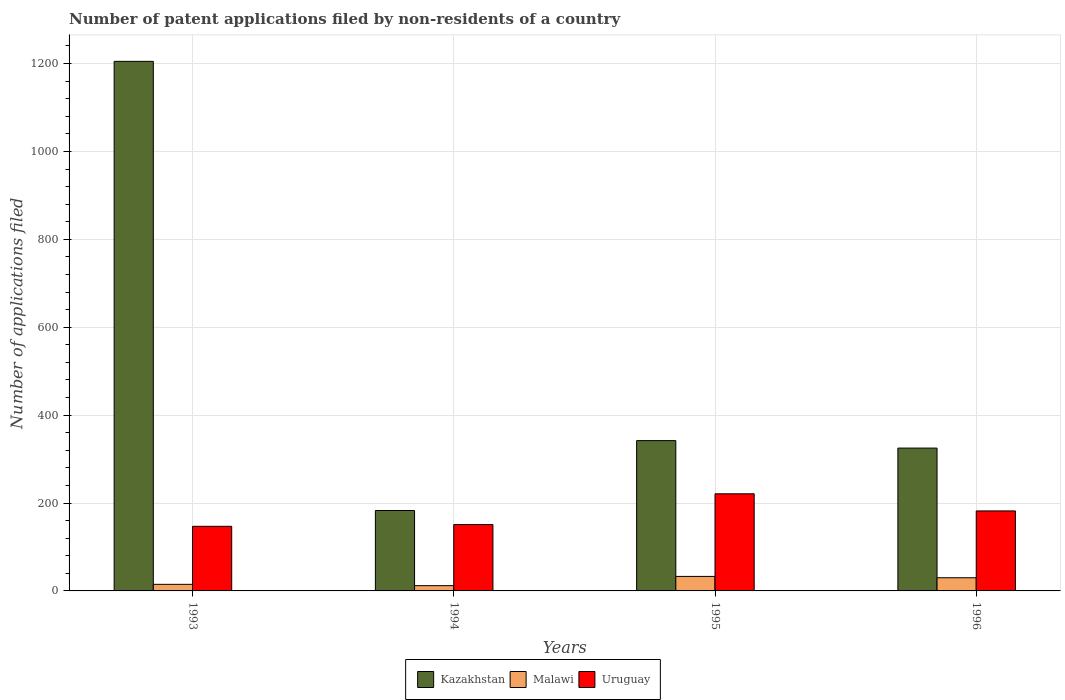How many groups of bars are there?
Offer a very short reply. 4. Are the number of bars per tick equal to the number of legend labels?
Make the answer very short. Yes. Are the number of bars on each tick of the X-axis equal?
Offer a terse response. Yes. How many bars are there on the 4th tick from the left?
Ensure brevity in your answer.  3. What is the label of the 1st group of bars from the left?
Your answer should be compact. 1993. What is the number of applications filed in Malawi in 1995?
Keep it short and to the point. 33. Across all years, what is the maximum number of applications filed in Kazakhstan?
Provide a short and direct response. 1205. In which year was the number of applications filed in Malawi maximum?
Ensure brevity in your answer.  1995. In which year was the number of applications filed in Uruguay minimum?
Ensure brevity in your answer.  1993. What is the total number of applications filed in Kazakhstan in the graph?
Offer a terse response. 2055. What is the difference between the number of applications filed in Kazakhstan in 1993 and that in 1995?
Make the answer very short. 863. What is the difference between the number of applications filed in Malawi in 1993 and the number of applications filed in Kazakhstan in 1995?
Offer a terse response. -327. What is the average number of applications filed in Uruguay per year?
Your answer should be very brief. 175.25. In the year 1995, what is the difference between the number of applications filed in Malawi and number of applications filed in Kazakhstan?
Provide a succinct answer. -309. What is the ratio of the number of applications filed in Uruguay in 1994 to that in 1996?
Offer a very short reply. 0.83. Is the difference between the number of applications filed in Malawi in 1994 and 1996 greater than the difference between the number of applications filed in Kazakhstan in 1994 and 1996?
Ensure brevity in your answer.  Yes. What is the difference between the highest and the second highest number of applications filed in Uruguay?
Provide a succinct answer. 39. In how many years, is the number of applications filed in Kazakhstan greater than the average number of applications filed in Kazakhstan taken over all years?
Provide a short and direct response. 1. What does the 2nd bar from the left in 1994 represents?
Provide a short and direct response. Malawi. What does the 2nd bar from the right in 1994 represents?
Offer a terse response. Malawi. Is it the case that in every year, the sum of the number of applications filed in Uruguay and number of applications filed in Malawi is greater than the number of applications filed in Kazakhstan?
Give a very brief answer. No. How many bars are there?
Your answer should be compact. 12. How many years are there in the graph?
Give a very brief answer. 4. Does the graph contain grids?
Ensure brevity in your answer.  Yes. How many legend labels are there?
Give a very brief answer. 3. How are the legend labels stacked?
Provide a short and direct response. Horizontal. What is the title of the graph?
Your answer should be very brief. Number of patent applications filed by non-residents of a country. Does "Angola" appear as one of the legend labels in the graph?
Make the answer very short. No. What is the label or title of the X-axis?
Keep it short and to the point. Years. What is the label or title of the Y-axis?
Ensure brevity in your answer.  Number of applications filed. What is the Number of applications filed of Kazakhstan in 1993?
Provide a succinct answer. 1205. What is the Number of applications filed of Uruguay in 1993?
Provide a short and direct response. 147. What is the Number of applications filed in Kazakhstan in 1994?
Offer a very short reply. 183. What is the Number of applications filed of Malawi in 1994?
Provide a short and direct response. 12. What is the Number of applications filed of Uruguay in 1994?
Ensure brevity in your answer.  151. What is the Number of applications filed of Kazakhstan in 1995?
Keep it short and to the point. 342. What is the Number of applications filed of Malawi in 1995?
Your response must be concise. 33. What is the Number of applications filed in Uruguay in 1995?
Ensure brevity in your answer.  221. What is the Number of applications filed of Kazakhstan in 1996?
Offer a very short reply. 325. What is the Number of applications filed in Malawi in 1996?
Offer a terse response. 30. What is the Number of applications filed of Uruguay in 1996?
Your response must be concise. 182. Across all years, what is the maximum Number of applications filed in Kazakhstan?
Offer a terse response. 1205. Across all years, what is the maximum Number of applications filed in Uruguay?
Make the answer very short. 221. Across all years, what is the minimum Number of applications filed in Kazakhstan?
Offer a very short reply. 183. Across all years, what is the minimum Number of applications filed in Uruguay?
Your answer should be very brief. 147. What is the total Number of applications filed of Kazakhstan in the graph?
Give a very brief answer. 2055. What is the total Number of applications filed in Uruguay in the graph?
Your response must be concise. 701. What is the difference between the Number of applications filed of Kazakhstan in 1993 and that in 1994?
Your answer should be very brief. 1022. What is the difference between the Number of applications filed of Malawi in 1993 and that in 1994?
Ensure brevity in your answer.  3. What is the difference between the Number of applications filed of Kazakhstan in 1993 and that in 1995?
Make the answer very short. 863. What is the difference between the Number of applications filed of Uruguay in 1993 and that in 1995?
Your answer should be compact. -74. What is the difference between the Number of applications filed in Kazakhstan in 1993 and that in 1996?
Offer a terse response. 880. What is the difference between the Number of applications filed of Malawi in 1993 and that in 1996?
Provide a succinct answer. -15. What is the difference between the Number of applications filed in Uruguay in 1993 and that in 1996?
Make the answer very short. -35. What is the difference between the Number of applications filed in Kazakhstan in 1994 and that in 1995?
Provide a short and direct response. -159. What is the difference between the Number of applications filed in Uruguay in 1994 and that in 1995?
Ensure brevity in your answer.  -70. What is the difference between the Number of applications filed in Kazakhstan in 1994 and that in 1996?
Ensure brevity in your answer.  -142. What is the difference between the Number of applications filed in Malawi in 1994 and that in 1996?
Offer a terse response. -18. What is the difference between the Number of applications filed in Uruguay in 1994 and that in 1996?
Provide a short and direct response. -31. What is the difference between the Number of applications filed of Malawi in 1995 and that in 1996?
Provide a succinct answer. 3. What is the difference between the Number of applications filed in Uruguay in 1995 and that in 1996?
Provide a succinct answer. 39. What is the difference between the Number of applications filed in Kazakhstan in 1993 and the Number of applications filed in Malawi in 1994?
Your answer should be compact. 1193. What is the difference between the Number of applications filed in Kazakhstan in 1993 and the Number of applications filed in Uruguay in 1994?
Your answer should be compact. 1054. What is the difference between the Number of applications filed of Malawi in 1993 and the Number of applications filed of Uruguay in 1994?
Your answer should be compact. -136. What is the difference between the Number of applications filed of Kazakhstan in 1993 and the Number of applications filed of Malawi in 1995?
Offer a very short reply. 1172. What is the difference between the Number of applications filed of Kazakhstan in 1993 and the Number of applications filed of Uruguay in 1995?
Ensure brevity in your answer.  984. What is the difference between the Number of applications filed of Malawi in 1993 and the Number of applications filed of Uruguay in 1995?
Make the answer very short. -206. What is the difference between the Number of applications filed of Kazakhstan in 1993 and the Number of applications filed of Malawi in 1996?
Your answer should be compact. 1175. What is the difference between the Number of applications filed in Kazakhstan in 1993 and the Number of applications filed in Uruguay in 1996?
Your answer should be very brief. 1023. What is the difference between the Number of applications filed in Malawi in 1993 and the Number of applications filed in Uruguay in 1996?
Offer a terse response. -167. What is the difference between the Number of applications filed of Kazakhstan in 1994 and the Number of applications filed of Malawi in 1995?
Offer a very short reply. 150. What is the difference between the Number of applications filed of Kazakhstan in 1994 and the Number of applications filed of Uruguay in 1995?
Your answer should be very brief. -38. What is the difference between the Number of applications filed in Malawi in 1994 and the Number of applications filed in Uruguay in 1995?
Offer a terse response. -209. What is the difference between the Number of applications filed in Kazakhstan in 1994 and the Number of applications filed in Malawi in 1996?
Give a very brief answer. 153. What is the difference between the Number of applications filed in Malawi in 1994 and the Number of applications filed in Uruguay in 1996?
Your response must be concise. -170. What is the difference between the Number of applications filed of Kazakhstan in 1995 and the Number of applications filed of Malawi in 1996?
Give a very brief answer. 312. What is the difference between the Number of applications filed of Kazakhstan in 1995 and the Number of applications filed of Uruguay in 1996?
Offer a very short reply. 160. What is the difference between the Number of applications filed of Malawi in 1995 and the Number of applications filed of Uruguay in 1996?
Your response must be concise. -149. What is the average Number of applications filed of Kazakhstan per year?
Make the answer very short. 513.75. What is the average Number of applications filed of Uruguay per year?
Make the answer very short. 175.25. In the year 1993, what is the difference between the Number of applications filed in Kazakhstan and Number of applications filed in Malawi?
Provide a short and direct response. 1190. In the year 1993, what is the difference between the Number of applications filed of Kazakhstan and Number of applications filed of Uruguay?
Keep it short and to the point. 1058. In the year 1993, what is the difference between the Number of applications filed in Malawi and Number of applications filed in Uruguay?
Make the answer very short. -132. In the year 1994, what is the difference between the Number of applications filed in Kazakhstan and Number of applications filed in Malawi?
Provide a short and direct response. 171. In the year 1994, what is the difference between the Number of applications filed in Kazakhstan and Number of applications filed in Uruguay?
Provide a succinct answer. 32. In the year 1994, what is the difference between the Number of applications filed in Malawi and Number of applications filed in Uruguay?
Your answer should be very brief. -139. In the year 1995, what is the difference between the Number of applications filed in Kazakhstan and Number of applications filed in Malawi?
Ensure brevity in your answer.  309. In the year 1995, what is the difference between the Number of applications filed in Kazakhstan and Number of applications filed in Uruguay?
Make the answer very short. 121. In the year 1995, what is the difference between the Number of applications filed in Malawi and Number of applications filed in Uruguay?
Offer a very short reply. -188. In the year 1996, what is the difference between the Number of applications filed in Kazakhstan and Number of applications filed in Malawi?
Your response must be concise. 295. In the year 1996, what is the difference between the Number of applications filed in Kazakhstan and Number of applications filed in Uruguay?
Keep it short and to the point. 143. In the year 1996, what is the difference between the Number of applications filed of Malawi and Number of applications filed of Uruguay?
Provide a succinct answer. -152. What is the ratio of the Number of applications filed in Kazakhstan in 1993 to that in 1994?
Ensure brevity in your answer.  6.58. What is the ratio of the Number of applications filed in Uruguay in 1993 to that in 1994?
Provide a short and direct response. 0.97. What is the ratio of the Number of applications filed of Kazakhstan in 1993 to that in 1995?
Your response must be concise. 3.52. What is the ratio of the Number of applications filed of Malawi in 1993 to that in 1995?
Your answer should be compact. 0.45. What is the ratio of the Number of applications filed of Uruguay in 1993 to that in 1995?
Offer a very short reply. 0.67. What is the ratio of the Number of applications filed of Kazakhstan in 1993 to that in 1996?
Keep it short and to the point. 3.71. What is the ratio of the Number of applications filed in Uruguay in 1993 to that in 1996?
Make the answer very short. 0.81. What is the ratio of the Number of applications filed of Kazakhstan in 1994 to that in 1995?
Give a very brief answer. 0.54. What is the ratio of the Number of applications filed in Malawi in 1994 to that in 1995?
Your response must be concise. 0.36. What is the ratio of the Number of applications filed in Uruguay in 1994 to that in 1995?
Your response must be concise. 0.68. What is the ratio of the Number of applications filed in Kazakhstan in 1994 to that in 1996?
Give a very brief answer. 0.56. What is the ratio of the Number of applications filed of Malawi in 1994 to that in 1996?
Keep it short and to the point. 0.4. What is the ratio of the Number of applications filed of Uruguay in 1994 to that in 1996?
Provide a short and direct response. 0.83. What is the ratio of the Number of applications filed of Kazakhstan in 1995 to that in 1996?
Your response must be concise. 1.05. What is the ratio of the Number of applications filed in Malawi in 1995 to that in 1996?
Ensure brevity in your answer.  1.1. What is the ratio of the Number of applications filed in Uruguay in 1995 to that in 1996?
Your response must be concise. 1.21. What is the difference between the highest and the second highest Number of applications filed in Kazakhstan?
Offer a very short reply. 863. What is the difference between the highest and the lowest Number of applications filed of Kazakhstan?
Offer a very short reply. 1022. What is the difference between the highest and the lowest Number of applications filed in Uruguay?
Offer a very short reply. 74. 